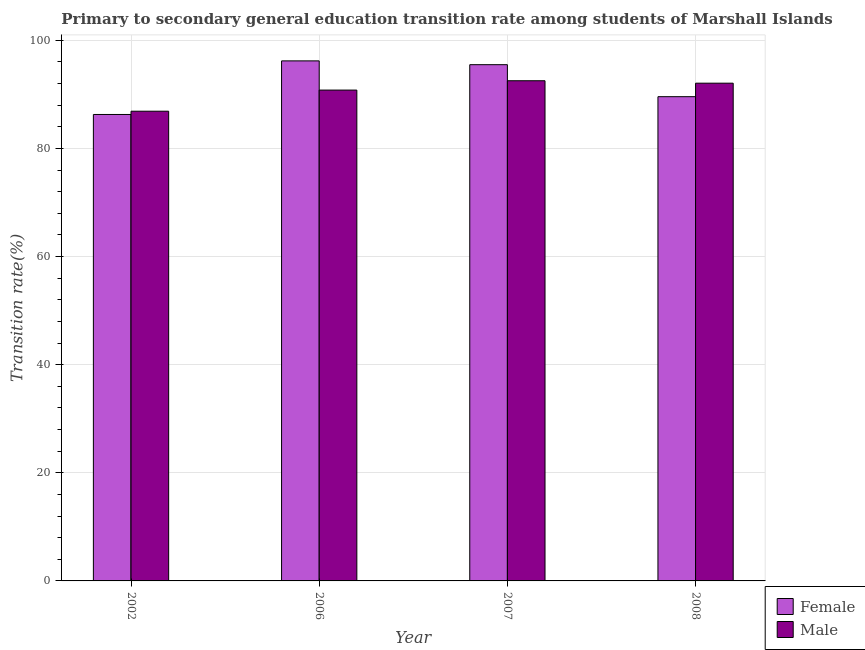Are the number of bars per tick equal to the number of legend labels?
Offer a terse response. Yes. Are the number of bars on each tick of the X-axis equal?
Your answer should be very brief. Yes. What is the label of the 1st group of bars from the left?
Your answer should be very brief. 2002. In how many cases, is the number of bars for a given year not equal to the number of legend labels?
Offer a very short reply. 0. What is the transition rate among female students in 2008?
Your answer should be very brief. 89.57. Across all years, what is the maximum transition rate among female students?
Give a very brief answer. 96.19. Across all years, what is the minimum transition rate among female students?
Provide a succinct answer. 86.27. In which year was the transition rate among female students maximum?
Offer a very short reply. 2006. In which year was the transition rate among female students minimum?
Keep it short and to the point. 2002. What is the total transition rate among female students in the graph?
Your answer should be compact. 367.51. What is the difference between the transition rate among female students in 2002 and that in 2007?
Ensure brevity in your answer.  -9.21. What is the difference between the transition rate among female students in 2006 and the transition rate among male students in 2007?
Your answer should be very brief. 0.7. What is the average transition rate among male students per year?
Offer a very short reply. 90.56. What is the ratio of the transition rate among male students in 2007 to that in 2008?
Your answer should be compact. 1. Is the difference between the transition rate among female students in 2002 and 2007 greater than the difference between the transition rate among male students in 2002 and 2007?
Ensure brevity in your answer.  No. What is the difference between the highest and the second highest transition rate among male students?
Make the answer very short. 0.45. What is the difference between the highest and the lowest transition rate among male students?
Your answer should be compact. 5.64. In how many years, is the transition rate among female students greater than the average transition rate among female students taken over all years?
Offer a terse response. 2. Is the sum of the transition rate among male students in 2002 and 2006 greater than the maximum transition rate among female students across all years?
Give a very brief answer. Yes. What does the 2nd bar from the left in 2007 represents?
Provide a short and direct response. Male. How many bars are there?
Your answer should be compact. 8. What is the difference between two consecutive major ticks on the Y-axis?
Make the answer very short. 20. How many legend labels are there?
Give a very brief answer. 2. What is the title of the graph?
Offer a very short reply. Primary to secondary general education transition rate among students of Marshall Islands. Does "Private creditors" appear as one of the legend labels in the graph?
Keep it short and to the point. No. What is the label or title of the X-axis?
Ensure brevity in your answer.  Year. What is the label or title of the Y-axis?
Your response must be concise. Transition rate(%). What is the Transition rate(%) of Female in 2002?
Offer a terse response. 86.27. What is the Transition rate(%) of Male in 2002?
Keep it short and to the point. 86.88. What is the Transition rate(%) of Female in 2006?
Offer a terse response. 96.19. What is the Transition rate(%) of Male in 2006?
Your answer should be compact. 90.78. What is the Transition rate(%) in Female in 2007?
Your response must be concise. 95.48. What is the Transition rate(%) in Male in 2007?
Ensure brevity in your answer.  92.51. What is the Transition rate(%) of Female in 2008?
Your answer should be very brief. 89.57. What is the Transition rate(%) of Male in 2008?
Your answer should be very brief. 92.06. Across all years, what is the maximum Transition rate(%) in Female?
Provide a succinct answer. 96.19. Across all years, what is the maximum Transition rate(%) of Male?
Give a very brief answer. 92.51. Across all years, what is the minimum Transition rate(%) of Female?
Your response must be concise. 86.27. Across all years, what is the minimum Transition rate(%) in Male?
Your response must be concise. 86.88. What is the total Transition rate(%) in Female in the graph?
Make the answer very short. 367.51. What is the total Transition rate(%) of Male in the graph?
Make the answer very short. 362.24. What is the difference between the Transition rate(%) in Female in 2002 and that in 2006?
Give a very brief answer. -9.91. What is the difference between the Transition rate(%) in Male in 2002 and that in 2006?
Give a very brief answer. -3.91. What is the difference between the Transition rate(%) in Female in 2002 and that in 2007?
Offer a terse response. -9.21. What is the difference between the Transition rate(%) in Male in 2002 and that in 2007?
Make the answer very short. -5.64. What is the difference between the Transition rate(%) in Female in 2002 and that in 2008?
Provide a succinct answer. -3.29. What is the difference between the Transition rate(%) of Male in 2002 and that in 2008?
Keep it short and to the point. -5.19. What is the difference between the Transition rate(%) in Female in 2006 and that in 2007?
Ensure brevity in your answer.  0.7. What is the difference between the Transition rate(%) in Male in 2006 and that in 2007?
Your answer should be very brief. -1.73. What is the difference between the Transition rate(%) in Female in 2006 and that in 2008?
Offer a terse response. 6.62. What is the difference between the Transition rate(%) in Male in 2006 and that in 2008?
Ensure brevity in your answer.  -1.28. What is the difference between the Transition rate(%) in Female in 2007 and that in 2008?
Make the answer very short. 5.92. What is the difference between the Transition rate(%) in Male in 2007 and that in 2008?
Your answer should be very brief. 0.45. What is the difference between the Transition rate(%) of Female in 2002 and the Transition rate(%) of Male in 2006?
Provide a succinct answer. -4.51. What is the difference between the Transition rate(%) of Female in 2002 and the Transition rate(%) of Male in 2007?
Your answer should be very brief. -6.24. What is the difference between the Transition rate(%) in Female in 2002 and the Transition rate(%) in Male in 2008?
Offer a terse response. -5.79. What is the difference between the Transition rate(%) in Female in 2006 and the Transition rate(%) in Male in 2007?
Your answer should be very brief. 3.67. What is the difference between the Transition rate(%) in Female in 2006 and the Transition rate(%) in Male in 2008?
Keep it short and to the point. 4.12. What is the difference between the Transition rate(%) of Female in 2007 and the Transition rate(%) of Male in 2008?
Provide a succinct answer. 3.42. What is the average Transition rate(%) in Female per year?
Ensure brevity in your answer.  91.88. What is the average Transition rate(%) of Male per year?
Give a very brief answer. 90.56. In the year 2002, what is the difference between the Transition rate(%) in Female and Transition rate(%) in Male?
Offer a terse response. -0.6. In the year 2006, what is the difference between the Transition rate(%) of Female and Transition rate(%) of Male?
Your answer should be compact. 5.4. In the year 2007, what is the difference between the Transition rate(%) of Female and Transition rate(%) of Male?
Ensure brevity in your answer.  2.97. In the year 2008, what is the difference between the Transition rate(%) of Female and Transition rate(%) of Male?
Make the answer very short. -2.5. What is the ratio of the Transition rate(%) of Female in 2002 to that in 2006?
Provide a short and direct response. 0.9. What is the ratio of the Transition rate(%) in Male in 2002 to that in 2006?
Offer a terse response. 0.96. What is the ratio of the Transition rate(%) of Female in 2002 to that in 2007?
Provide a short and direct response. 0.9. What is the ratio of the Transition rate(%) in Male in 2002 to that in 2007?
Provide a succinct answer. 0.94. What is the ratio of the Transition rate(%) of Female in 2002 to that in 2008?
Your answer should be very brief. 0.96. What is the ratio of the Transition rate(%) of Male in 2002 to that in 2008?
Your answer should be compact. 0.94. What is the ratio of the Transition rate(%) of Female in 2006 to that in 2007?
Your response must be concise. 1.01. What is the ratio of the Transition rate(%) in Male in 2006 to that in 2007?
Your response must be concise. 0.98. What is the ratio of the Transition rate(%) of Female in 2006 to that in 2008?
Provide a short and direct response. 1.07. What is the ratio of the Transition rate(%) of Male in 2006 to that in 2008?
Give a very brief answer. 0.99. What is the ratio of the Transition rate(%) in Female in 2007 to that in 2008?
Your answer should be very brief. 1.07. What is the ratio of the Transition rate(%) in Male in 2007 to that in 2008?
Your response must be concise. 1. What is the difference between the highest and the second highest Transition rate(%) of Female?
Offer a terse response. 0.7. What is the difference between the highest and the second highest Transition rate(%) of Male?
Provide a short and direct response. 0.45. What is the difference between the highest and the lowest Transition rate(%) of Female?
Offer a terse response. 9.91. What is the difference between the highest and the lowest Transition rate(%) in Male?
Your answer should be very brief. 5.64. 